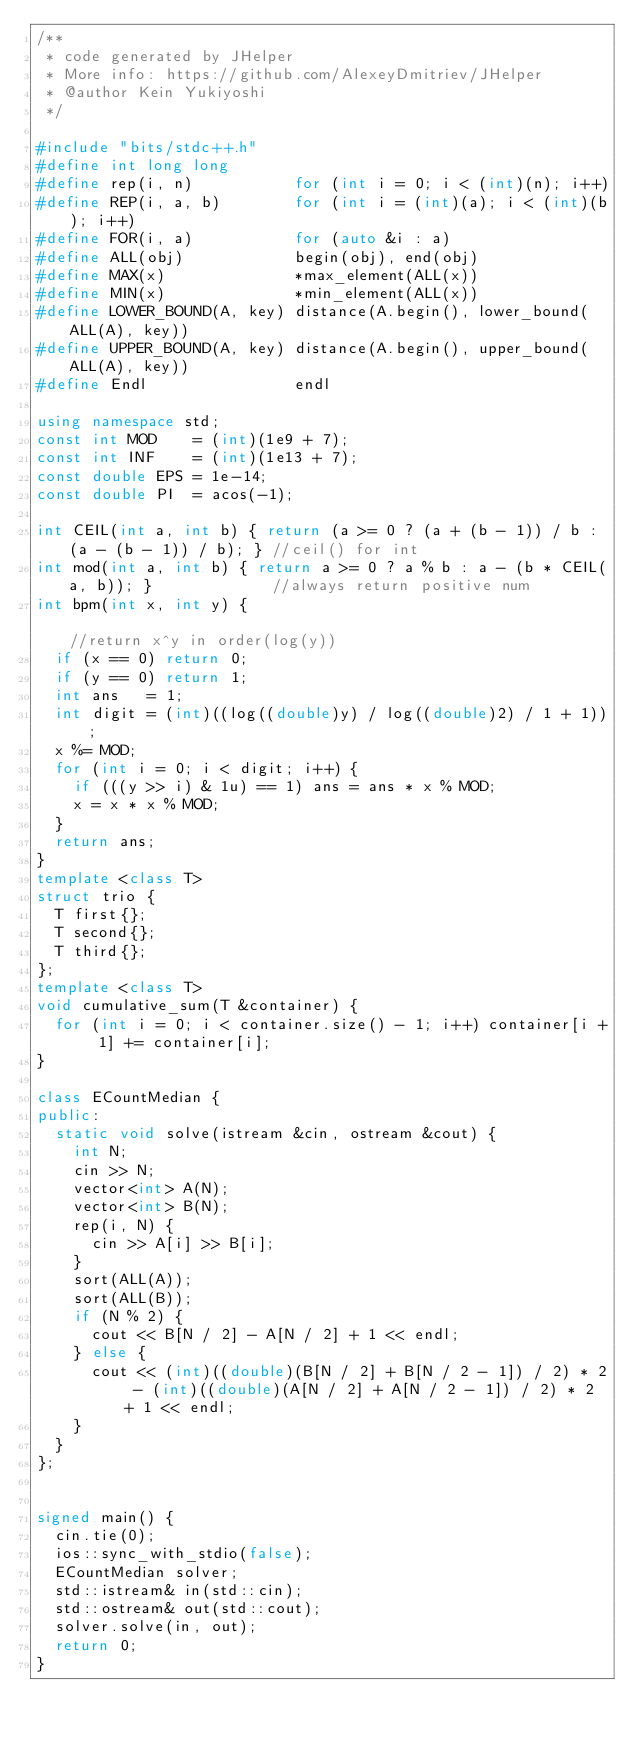<code> <loc_0><loc_0><loc_500><loc_500><_C++_>/**
 * code generated by JHelper
 * More info: https://github.com/AlexeyDmitriev/JHelper
 * @author Kein Yukiyoshi
 */

#include "bits/stdc++.h"
#define int long long
#define rep(i, n)           for (int i = 0; i < (int)(n); i++)
#define REP(i, a, b)        for (int i = (int)(a); i < (int)(b); i++)
#define FOR(i, a)           for (auto &i : a)
#define ALL(obj)            begin(obj), end(obj)
#define MAX(x)              *max_element(ALL(x))
#define MIN(x)              *min_element(ALL(x))
#define LOWER_BOUND(A, key) distance(A.begin(), lower_bound(ALL(A), key))
#define UPPER_BOUND(A, key) distance(A.begin(), upper_bound(ALL(A), key))
#define Endl                endl

using namespace std;
const int MOD    = (int)(1e9 + 7);
const int INF    = (int)(1e13 + 7);
const double EPS = 1e-14;
const double PI  = acos(-1);

int CEIL(int a, int b) { return (a >= 0 ? (a + (b - 1)) / b : (a - (b - 1)) / b); } //ceil() for int
int mod(int a, int b) { return a >= 0 ? a % b : a - (b * CEIL(a, b)); }             //always return positive num
int bpm(int x, int y) {                                                             //return x^y in order(log(y))
  if (x == 0) return 0;
  if (y == 0) return 1;
  int ans   = 1;
  int digit = (int)((log((double)y) / log((double)2) / 1 + 1));
  x %= MOD;
  for (int i = 0; i < digit; i++) {
    if (((y >> i) & 1u) == 1) ans = ans * x % MOD;
    x = x * x % MOD;
  }
  return ans;
}
template <class T>
struct trio {
  T first{};
  T second{};
  T third{};
};
template <class T>
void cumulative_sum(T &container) {
  for (int i = 0; i < container.size() - 1; i++) container[i + 1] += container[i];
}

class ECountMedian {
public:
  static void solve(istream &cin, ostream &cout) {
    int N;
    cin >> N;
    vector<int> A(N);
    vector<int> B(N);
    rep(i, N) {
      cin >> A[i] >> B[i];
    }
    sort(ALL(A));
    sort(ALL(B));
    if (N % 2) {
      cout << B[N / 2] - A[N / 2] + 1 << endl;
    } else {
      cout << (int)((double)(B[N / 2] + B[N / 2 - 1]) / 2) * 2 - (int)((double)(A[N / 2] + A[N / 2 - 1]) / 2) * 2 + 1 << endl;
    }
  }
};


signed main() {
  cin.tie(0);
  ios::sync_with_stdio(false);
  ECountMedian solver;
  std::istream& in(std::cin);
  std::ostream& out(std::cout);
  solver.solve(in, out);
  return 0;
}
</code> 